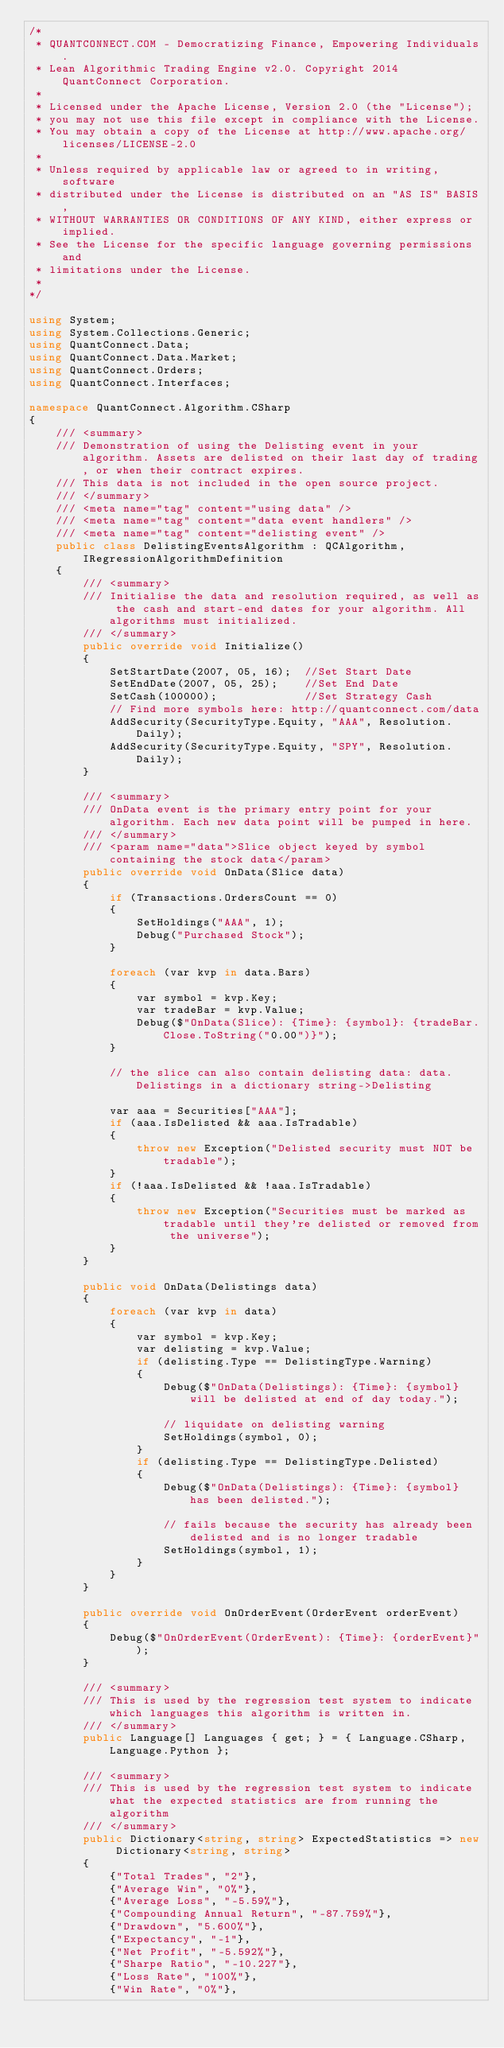Convert code to text. <code><loc_0><loc_0><loc_500><loc_500><_C#_>/*
 * QUANTCONNECT.COM - Democratizing Finance, Empowering Individuals.
 * Lean Algorithmic Trading Engine v2.0. Copyright 2014 QuantConnect Corporation.
 *
 * Licensed under the Apache License, Version 2.0 (the "License");
 * you may not use this file except in compliance with the License.
 * You may obtain a copy of the License at http://www.apache.org/licenses/LICENSE-2.0
 *
 * Unless required by applicable law or agreed to in writing, software
 * distributed under the License is distributed on an "AS IS" BASIS,
 * WITHOUT WARRANTIES OR CONDITIONS OF ANY KIND, either express or implied.
 * See the License for the specific language governing permissions and
 * limitations under the License.
 *
*/

using System;
using System.Collections.Generic;
using QuantConnect.Data;
using QuantConnect.Data.Market;
using QuantConnect.Orders;
using QuantConnect.Interfaces;

namespace QuantConnect.Algorithm.CSharp
{
    /// <summary>
    /// Demonstration of using the Delisting event in your algorithm. Assets are delisted on their last day of trading, or when their contract expires.
    /// This data is not included in the open source project.
    /// </summary>
    /// <meta name="tag" content="using data" />
    /// <meta name="tag" content="data event handlers" />
    /// <meta name="tag" content="delisting event" />
    public class DelistingEventsAlgorithm : QCAlgorithm, IRegressionAlgorithmDefinition
    {
        /// <summary>
        /// Initialise the data and resolution required, as well as the cash and start-end dates for your algorithm. All algorithms must initialized.
        /// </summary>
        public override void Initialize()
        {
            SetStartDate(2007, 05, 16);  //Set Start Date
            SetEndDate(2007, 05, 25);    //Set End Date
            SetCash(100000);             //Set Strategy Cash
            // Find more symbols here: http://quantconnect.com/data
            AddSecurity(SecurityType.Equity, "AAA", Resolution.Daily);
            AddSecurity(SecurityType.Equity, "SPY", Resolution.Daily);
        }

        /// <summary>
        /// OnData event is the primary entry point for your algorithm. Each new data point will be pumped in here.
        /// </summary>
        /// <param name="data">Slice object keyed by symbol containing the stock data</param>
        public override void OnData(Slice data)
        {
            if (Transactions.OrdersCount == 0)
            {
                SetHoldings("AAA", 1);
                Debug("Purchased Stock");
            }

            foreach (var kvp in data.Bars)
            {
                var symbol = kvp.Key;
                var tradeBar = kvp.Value;
                Debug($"OnData(Slice): {Time}: {symbol}: {tradeBar.Close.ToString("0.00")}");
            }

            // the slice can also contain delisting data: data.Delistings in a dictionary string->Delisting

            var aaa = Securities["AAA"];
            if (aaa.IsDelisted && aaa.IsTradable)
            {
                throw new Exception("Delisted security must NOT be tradable");
            }
            if (!aaa.IsDelisted && !aaa.IsTradable)
            {
                throw new Exception("Securities must be marked as tradable until they're delisted or removed from the universe");
            }
        }

        public void OnData(Delistings data)
        {
            foreach (var kvp in data)
            {
                var symbol = kvp.Key;
                var delisting = kvp.Value;
                if (delisting.Type == DelistingType.Warning)
                {
                    Debug($"OnData(Delistings): {Time}: {symbol} will be delisted at end of day today.");

                    // liquidate on delisting warning
                    SetHoldings(symbol, 0);
                }
                if (delisting.Type == DelistingType.Delisted)
                {
                    Debug($"OnData(Delistings): {Time}: {symbol} has been delisted.");

                    // fails because the security has already been delisted and is no longer tradable
                    SetHoldings(symbol, 1);
                }
            }
        }

        public override void OnOrderEvent(OrderEvent orderEvent)
        {
            Debug($"OnOrderEvent(OrderEvent): {Time}: {orderEvent}");
        }

        /// <summary>
        /// This is used by the regression test system to indicate which languages this algorithm is written in.
        /// </summary>
        public Language[] Languages { get; } = { Language.CSharp, Language.Python };

        /// <summary>
        /// This is used by the regression test system to indicate what the expected statistics are from running the algorithm
        /// </summary>
        public Dictionary<string, string> ExpectedStatistics => new Dictionary<string, string>
        {
            {"Total Trades", "2"},
            {"Average Win", "0%"},
            {"Average Loss", "-5.59%"},
            {"Compounding Annual Return", "-87.759%"},
            {"Drawdown", "5.600%"},
            {"Expectancy", "-1"},
            {"Net Profit", "-5.592%"},
            {"Sharpe Ratio", "-10.227"},
            {"Loss Rate", "100%"},
            {"Win Rate", "0%"},</code> 